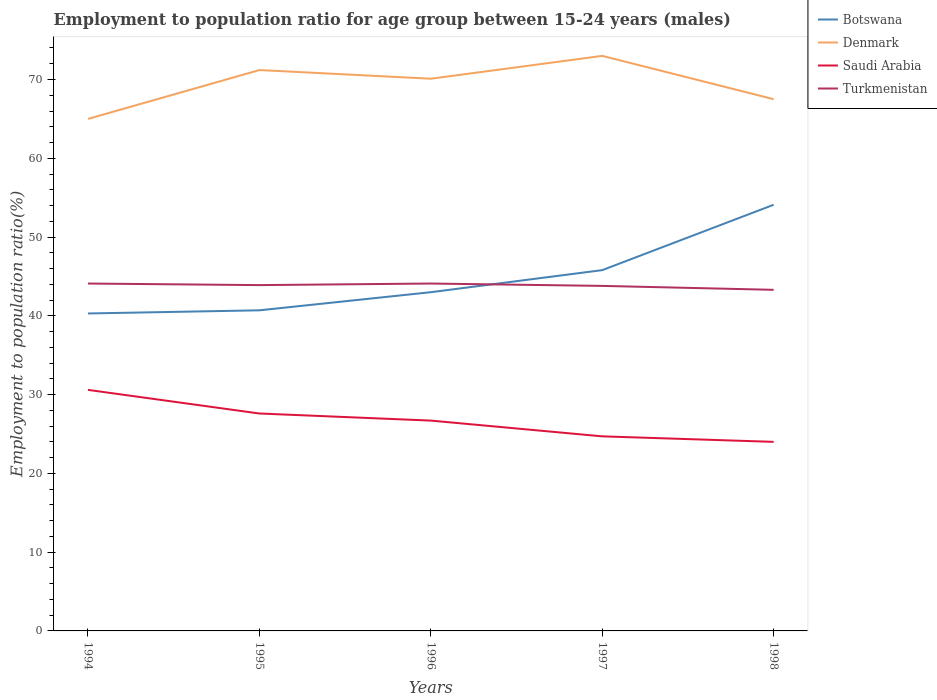Is the number of lines equal to the number of legend labels?
Provide a short and direct response. Yes. Across all years, what is the maximum employment to population ratio in Saudi Arabia?
Your response must be concise. 24. In which year was the employment to population ratio in Denmark maximum?
Make the answer very short. 1994. What is the total employment to population ratio in Saudi Arabia in the graph?
Your response must be concise. 0.9. What is the difference between the highest and the second highest employment to population ratio in Turkmenistan?
Ensure brevity in your answer.  0.8. Is the employment to population ratio in Botswana strictly greater than the employment to population ratio in Saudi Arabia over the years?
Provide a short and direct response. No. How many lines are there?
Your answer should be very brief. 4. How many years are there in the graph?
Make the answer very short. 5. What is the difference between two consecutive major ticks on the Y-axis?
Keep it short and to the point. 10. Does the graph contain grids?
Keep it short and to the point. No. Where does the legend appear in the graph?
Offer a terse response. Top right. How are the legend labels stacked?
Give a very brief answer. Vertical. What is the title of the graph?
Your response must be concise. Employment to population ratio for age group between 15-24 years (males). Does "Lebanon" appear as one of the legend labels in the graph?
Keep it short and to the point. No. What is the label or title of the Y-axis?
Offer a very short reply. Employment to population ratio(%). What is the Employment to population ratio(%) in Botswana in 1994?
Ensure brevity in your answer.  40.3. What is the Employment to population ratio(%) of Denmark in 1994?
Make the answer very short. 65. What is the Employment to population ratio(%) of Saudi Arabia in 1994?
Give a very brief answer. 30.6. What is the Employment to population ratio(%) of Turkmenistan in 1994?
Give a very brief answer. 44.1. What is the Employment to population ratio(%) of Botswana in 1995?
Make the answer very short. 40.7. What is the Employment to population ratio(%) in Denmark in 1995?
Offer a terse response. 71.2. What is the Employment to population ratio(%) in Saudi Arabia in 1995?
Your answer should be compact. 27.6. What is the Employment to population ratio(%) in Turkmenistan in 1995?
Provide a short and direct response. 43.9. What is the Employment to population ratio(%) of Denmark in 1996?
Make the answer very short. 70.1. What is the Employment to population ratio(%) in Saudi Arabia in 1996?
Your response must be concise. 26.7. What is the Employment to population ratio(%) in Turkmenistan in 1996?
Your answer should be very brief. 44.1. What is the Employment to population ratio(%) in Botswana in 1997?
Keep it short and to the point. 45.8. What is the Employment to population ratio(%) in Denmark in 1997?
Provide a short and direct response. 73. What is the Employment to population ratio(%) in Saudi Arabia in 1997?
Give a very brief answer. 24.7. What is the Employment to population ratio(%) in Turkmenistan in 1997?
Ensure brevity in your answer.  43.8. What is the Employment to population ratio(%) in Botswana in 1998?
Give a very brief answer. 54.1. What is the Employment to population ratio(%) in Denmark in 1998?
Give a very brief answer. 67.5. What is the Employment to population ratio(%) in Saudi Arabia in 1998?
Provide a short and direct response. 24. What is the Employment to population ratio(%) in Turkmenistan in 1998?
Ensure brevity in your answer.  43.3. Across all years, what is the maximum Employment to population ratio(%) in Botswana?
Your response must be concise. 54.1. Across all years, what is the maximum Employment to population ratio(%) of Saudi Arabia?
Ensure brevity in your answer.  30.6. Across all years, what is the maximum Employment to population ratio(%) in Turkmenistan?
Offer a very short reply. 44.1. Across all years, what is the minimum Employment to population ratio(%) of Botswana?
Ensure brevity in your answer.  40.3. Across all years, what is the minimum Employment to population ratio(%) in Saudi Arabia?
Your answer should be very brief. 24. Across all years, what is the minimum Employment to population ratio(%) of Turkmenistan?
Make the answer very short. 43.3. What is the total Employment to population ratio(%) in Botswana in the graph?
Ensure brevity in your answer.  223.9. What is the total Employment to population ratio(%) in Denmark in the graph?
Provide a short and direct response. 346.8. What is the total Employment to population ratio(%) in Saudi Arabia in the graph?
Make the answer very short. 133.6. What is the total Employment to population ratio(%) of Turkmenistan in the graph?
Ensure brevity in your answer.  219.2. What is the difference between the Employment to population ratio(%) of Botswana in 1994 and that in 1995?
Offer a very short reply. -0.4. What is the difference between the Employment to population ratio(%) of Denmark in 1994 and that in 1995?
Keep it short and to the point. -6.2. What is the difference between the Employment to population ratio(%) of Turkmenistan in 1994 and that in 1995?
Your answer should be compact. 0.2. What is the difference between the Employment to population ratio(%) in Turkmenistan in 1994 and that in 1996?
Offer a very short reply. 0. What is the difference between the Employment to population ratio(%) in Botswana in 1994 and that in 1997?
Offer a terse response. -5.5. What is the difference between the Employment to population ratio(%) of Turkmenistan in 1994 and that in 1997?
Make the answer very short. 0.3. What is the difference between the Employment to population ratio(%) of Botswana in 1994 and that in 1998?
Keep it short and to the point. -13.8. What is the difference between the Employment to population ratio(%) in Saudi Arabia in 1994 and that in 1998?
Give a very brief answer. 6.6. What is the difference between the Employment to population ratio(%) in Turkmenistan in 1994 and that in 1998?
Offer a terse response. 0.8. What is the difference between the Employment to population ratio(%) in Botswana in 1995 and that in 1996?
Ensure brevity in your answer.  -2.3. What is the difference between the Employment to population ratio(%) in Turkmenistan in 1995 and that in 1996?
Provide a short and direct response. -0.2. What is the difference between the Employment to population ratio(%) of Botswana in 1995 and that in 1997?
Ensure brevity in your answer.  -5.1. What is the difference between the Employment to population ratio(%) of Denmark in 1995 and that in 1997?
Offer a terse response. -1.8. What is the difference between the Employment to population ratio(%) of Denmark in 1995 and that in 1998?
Your answer should be compact. 3.7. What is the difference between the Employment to population ratio(%) of Botswana in 1996 and that in 1997?
Keep it short and to the point. -2.8. What is the difference between the Employment to population ratio(%) in Denmark in 1996 and that in 1997?
Provide a succinct answer. -2.9. What is the difference between the Employment to population ratio(%) in Saudi Arabia in 1996 and that in 1997?
Make the answer very short. 2. What is the difference between the Employment to population ratio(%) of Turkmenistan in 1996 and that in 1997?
Your answer should be compact. 0.3. What is the difference between the Employment to population ratio(%) in Turkmenistan in 1996 and that in 1998?
Provide a succinct answer. 0.8. What is the difference between the Employment to population ratio(%) in Botswana in 1994 and the Employment to population ratio(%) in Denmark in 1995?
Your response must be concise. -30.9. What is the difference between the Employment to population ratio(%) of Botswana in 1994 and the Employment to population ratio(%) of Saudi Arabia in 1995?
Your answer should be very brief. 12.7. What is the difference between the Employment to population ratio(%) in Botswana in 1994 and the Employment to population ratio(%) in Turkmenistan in 1995?
Provide a succinct answer. -3.6. What is the difference between the Employment to population ratio(%) of Denmark in 1994 and the Employment to population ratio(%) of Saudi Arabia in 1995?
Keep it short and to the point. 37.4. What is the difference between the Employment to population ratio(%) in Denmark in 1994 and the Employment to population ratio(%) in Turkmenistan in 1995?
Ensure brevity in your answer.  21.1. What is the difference between the Employment to population ratio(%) in Botswana in 1994 and the Employment to population ratio(%) in Denmark in 1996?
Your response must be concise. -29.8. What is the difference between the Employment to population ratio(%) in Botswana in 1994 and the Employment to population ratio(%) in Saudi Arabia in 1996?
Offer a terse response. 13.6. What is the difference between the Employment to population ratio(%) of Denmark in 1994 and the Employment to population ratio(%) of Saudi Arabia in 1996?
Your response must be concise. 38.3. What is the difference between the Employment to population ratio(%) of Denmark in 1994 and the Employment to population ratio(%) of Turkmenistan in 1996?
Keep it short and to the point. 20.9. What is the difference between the Employment to population ratio(%) of Botswana in 1994 and the Employment to population ratio(%) of Denmark in 1997?
Your response must be concise. -32.7. What is the difference between the Employment to population ratio(%) in Denmark in 1994 and the Employment to population ratio(%) in Saudi Arabia in 1997?
Keep it short and to the point. 40.3. What is the difference between the Employment to population ratio(%) of Denmark in 1994 and the Employment to population ratio(%) of Turkmenistan in 1997?
Your response must be concise. 21.2. What is the difference between the Employment to population ratio(%) of Botswana in 1994 and the Employment to population ratio(%) of Denmark in 1998?
Offer a very short reply. -27.2. What is the difference between the Employment to population ratio(%) in Denmark in 1994 and the Employment to population ratio(%) in Saudi Arabia in 1998?
Provide a short and direct response. 41. What is the difference between the Employment to population ratio(%) in Denmark in 1994 and the Employment to population ratio(%) in Turkmenistan in 1998?
Your answer should be very brief. 21.7. What is the difference between the Employment to population ratio(%) in Saudi Arabia in 1994 and the Employment to population ratio(%) in Turkmenistan in 1998?
Your response must be concise. -12.7. What is the difference between the Employment to population ratio(%) of Botswana in 1995 and the Employment to population ratio(%) of Denmark in 1996?
Offer a terse response. -29.4. What is the difference between the Employment to population ratio(%) in Denmark in 1995 and the Employment to population ratio(%) in Saudi Arabia in 1996?
Provide a short and direct response. 44.5. What is the difference between the Employment to population ratio(%) in Denmark in 1995 and the Employment to population ratio(%) in Turkmenistan in 1996?
Your answer should be very brief. 27.1. What is the difference between the Employment to population ratio(%) of Saudi Arabia in 1995 and the Employment to population ratio(%) of Turkmenistan in 1996?
Your answer should be compact. -16.5. What is the difference between the Employment to population ratio(%) of Botswana in 1995 and the Employment to population ratio(%) of Denmark in 1997?
Offer a terse response. -32.3. What is the difference between the Employment to population ratio(%) in Botswana in 1995 and the Employment to population ratio(%) in Saudi Arabia in 1997?
Give a very brief answer. 16. What is the difference between the Employment to population ratio(%) in Botswana in 1995 and the Employment to population ratio(%) in Turkmenistan in 1997?
Make the answer very short. -3.1. What is the difference between the Employment to population ratio(%) in Denmark in 1995 and the Employment to population ratio(%) in Saudi Arabia in 1997?
Provide a succinct answer. 46.5. What is the difference between the Employment to population ratio(%) of Denmark in 1995 and the Employment to population ratio(%) of Turkmenistan in 1997?
Offer a very short reply. 27.4. What is the difference between the Employment to population ratio(%) of Saudi Arabia in 1995 and the Employment to population ratio(%) of Turkmenistan in 1997?
Give a very brief answer. -16.2. What is the difference between the Employment to population ratio(%) in Botswana in 1995 and the Employment to population ratio(%) in Denmark in 1998?
Offer a terse response. -26.8. What is the difference between the Employment to population ratio(%) in Denmark in 1995 and the Employment to population ratio(%) in Saudi Arabia in 1998?
Give a very brief answer. 47.2. What is the difference between the Employment to population ratio(%) of Denmark in 1995 and the Employment to population ratio(%) of Turkmenistan in 1998?
Provide a short and direct response. 27.9. What is the difference between the Employment to population ratio(%) in Saudi Arabia in 1995 and the Employment to population ratio(%) in Turkmenistan in 1998?
Provide a short and direct response. -15.7. What is the difference between the Employment to population ratio(%) in Botswana in 1996 and the Employment to population ratio(%) in Denmark in 1997?
Your response must be concise. -30. What is the difference between the Employment to population ratio(%) of Botswana in 1996 and the Employment to population ratio(%) of Saudi Arabia in 1997?
Ensure brevity in your answer.  18.3. What is the difference between the Employment to population ratio(%) of Botswana in 1996 and the Employment to population ratio(%) of Turkmenistan in 1997?
Give a very brief answer. -0.8. What is the difference between the Employment to population ratio(%) of Denmark in 1996 and the Employment to population ratio(%) of Saudi Arabia in 1997?
Your answer should be compact. 45.4. What is the difference between the Employment to population ratio(%) of Denmark in 1996 and the Employment to population ratio(%) of Turkmenistan in 1997?
Your answer should be compact. 26.3. What is the difference between the Employment to population ratio(%) of Saudi Arabia in 1996 and the Employment to population ratio(%) of Turkmenistan in 1997?
Make the answer very short. -17.1. What is the difference between the Employment to population ratio(%) of Botswana in 1996 and the Employment to population ratio(%) of Denmark in 1998?
Your answer should be very brief. -24.5. What is the difference between the Employment to population ratio(%) of Botswana in 1996 and the Employment to population ratio(%) of Saudi Arabia in 1998?
Offer a terse response. 19. What is the difference between the Employment to population ratio(%) in Botswana in 1996 and the Employment to population ratio(%) in Turkmenistan in 1998?
Your response must be concise. -0.3. What is the difference between the Employment to population ratio(%) of Denmark in 1996 and the Employment to population ratio(%) of Saudi Arabia in 1998?
Give a very brief answer. 46.1. What is the difference between the Employment to population ratio(%) of Denmark in 1996 and the Employment to population ratio(%) of Turkmenistan in 1998?
Ensure brevity in your answer.  26.8. What is the difference between the Employment to population ratio(%) of Saudi Arabia in 1996 and the Employment to population ratio(%) of Turkmenistan in 1998?
Offer a very short reply. -16.6. What is the difference between the Employment to population ratio(%) in Botswana in 1997 and the Employment to population ratio(%) in Denmark in 1998?
Make the answer very short. -21.7. What is the difference between the Employment to population ratio(%) of Botswana in 1997 and the Employment to population ratio(%) of Saudi Arabia in 1998?
Make the answer very short. 21.8. What is the difference between the Employment to population ratio(%) in Denmark in 1997 and the Employment to population ratio(%) in Saudi Arabia in 1998?
Keep it short and to the point. 49. What is the difference between the Employment to population ratio(%) of Denmark in 1997 and the Employment to population ratio(%) of Turkmenistan in 1998?
Make the answer very short. 29.7. What is the difference between the Employment to population ratio(%) in Saudi Arabia in 1997 and the Employment to population ratio(%) in Turkmenistan in 1998?
Offer a very short reply. -18.6. What is the average Employment to population ratio(%) of Botswana per year?
Provide a short and direct response. 44.78. What is the average Employment to population ratio(%) of Denmark per year?
Your response must be concise. 69.36. What is the average Employment to population ratio(%) of Saudi Arabia per year?
Your response must be concise. 26.72. What is the average Employment to population ratio(%) in Turkmenistan per year?
Ensure brevity in your answer.  43.84. In the year 1994, what is the difference between the Employment to population ratio(%) in Botswana and Employment to population ratio(%) in Denmark?
Ensure brevity in your answer.  -24.7. In the year 1994, what is the difference between the Employment to population ratio(%) in Botswana and Employment to population ratio(%) in Turkmenistan?
Your answer should be very brief. -3.8. In the year 1994, what is the difference between the Employment to population ratio(%) in Denmark and Employment to population ratio(%) in Saudi Arabia?
Offer a very short reply. 34.4. In the year 1994, what is the difference between the Employment to population ratio(%) in Denmark and Employment to population ratio(%) in Turkmenistan?
Your answer should be very brief. 20.9. In the year 1995, what is the difference between the Employment to population ratio(%) in Botswana and Employment to population ratio(%) in Denmark?
Offer a very short reply. -30.5. In the year 1995, what is the difference between the Employment to population ratio(%) in Botswana and Employment to population ratio(%) in Turkmenistan?
Ensure brevity in your answer.  -3.2. In the year 1995, what is the difference between the Employment to population ratio(%) in Denmark and Employment to population ratio(%) in Saudi Arabia?
Provide a succinct answer. 43.6. In the year 1995, what is the difference between the Employment to population ratio(%) of Denmark and Employment to population ratio(%) of Turkmenistan?
Give a very brief answer. 27.3. In the year 1995, what is the difference between the Employment to population ratio(%) of Saudi Arabia and Employment to population ratio(%) of Turkmenistan?
Make the answer very short. -16.3. In the year 1996, what is the difference between the Employment to population ratio(%) in Botswana and Employment to population ratio(%) in Denmark?
Ensure brevity in your answer.  -27.1. In the year 1996, what is the difference between the Employment to population ratio(%) in Botswana and Employment to population ratio(%) in Turkmenistan?
Provide a short and direct response. -1.1. In the year 1996, what is the difference between the Employment to population ratio(%) in Denmark and Employment to population ratio(%) in Saudi Arabia?
Provide a short and direct response. 43.4. In the year 1996, what is the difference between the Employment to population ratio(%) in Saudi Arabia and Employment to population ratio(%) in Turkmenistan?
Ensure brevity in your answer.  -17.4. In the year 1997, what is the difference between the Employment to population ratio(%) of Botswana and Employment to population ratio(%) of Denmark?
Keep it short and to the point. -27.2. In the year 1997, what is the difference between the Employment to population ratio(%) in Botswana and Employment to population ratio(%) in Saudi Arabia?
Your response must be concise. 21.1. In the year 1997, what is the difference between the Employment to population ratio(%) of Botswana and Employment to population ratio(%) of Turkmenistan?
Your answer should be compact. 2. In the year 1997, what is the difference between the Employment to population ratio(%) of Denmark and Employment to population ratio(%) of Saudi Arabia?
Keep it short and to the point. 48.3. In the year 1997, what is the difference between the Employment to population ratio(%) in Denmark and Employment to population ratio(%) in Turkmenistan?
Make the answer very short. 29.2. In the year 1997, what is the difference between the Employment to population ratio(%) in Saudi Arabia and Employment to population ratio(%) in Turkmenistan?
Your response must be concise. -19.1. In the year 1998, what is the difference between the Employment to population ratio(%) of Botswana and Employment to population ratio(%) of Denmark?
Keep it short and to the point. -13.4. In the year 1998, what is the difference between the Employment to population ratio(%) in Botswana and Employment to population ratio(%) in Saudi Arabia?
Make the answer very short. 30.1. In the year 1998, what is the difference between the Employment to population ratio(%) in Botswana and Employment to population ratio(%) in Turkmenistan?
Your answer should be compact. 10.8. In the year 1998, what is the difference between the Employment to population ratio(%) of Denmark and Employment to population ratio(%) of Saudi Arabia?
Keep it short and to the point. 43.5. In the year 1998, what is the difference between the Employment to population ratio(%) in Denmark and Employment to population ratio(%) in Turkmenistan?
Offer a very short reply. 24.2. In the year 1998, what is the difference between the Employment to population ratio(%) in Saudi Arabia and Employment to population ratio(%) in Turkmenistan?
Offer a terse response. -19.3. What is the ratio of the Employment to population ratio(%) in Botswana in 1994 to that in 1995?
Offer a terse response. 0.99. What is the ratio of the Employment to population ratio(%) in Denmark in 1994 to that in 1995?
Your response must be concise. 0.91. What is the ratio of the Employment to population ratio(%) of Saudi Arabia in 1994 to that in 1995?
Give a very brief answer. 1.11. What is the ratio of the Employment to population ratio(%) in Botswana in 1994 to that in 1996?
Your response must be concise. 0.94. What is the ratio of the Employment to population ratio(%) in Denmark in 1994 to that in 1996?
Keep it short and to the point. 0.93. What is the ratio of the Employment to population ratio(%) of Saudi Arabia in 1994 to that in 1996?
Provide a short and direct response. 1.15. What is the ratio of the Employment to population ratio(%) in Turkmenistan in 1994 to that in 1996?
Offer a terse response. 1. What is the ratio of the Employment to population ratio(%) of Botswana in 1994 to that in 1997?
Your answer should be compact. 0.88. What is the ratio of the Employment to population ratio(%) in Denmark in 1994 to that in 1997?
Provide a succinct answer. 0.89. What is the ratio of the Employment to population ratio(%) in Saudi Arabia in 1994 to that in 1997?
Offer a terse response. 1.24. What is the ratio of the Employment to population ratio(%) in Turkmenistan in 1994 to that in 1997?
Keep it short and to the point. 1.01. What is the ratio of the Employment to population ratio(%) of Botswana in 1994 to that in 1998?
Your response must be concise. 0.74. What is the ratio of the Employment to population ratio(%) in Denmark in 1994 to that in 1998?
Offer a terse response. 0.96. What is the ratio of the Employment to population ratio(%) of Saudi Arabia in 1994 to that in 1998?
Your response must be concise. 1.27. What is the ratio of the Employment to population ratio(%) in Turkmenistan in 1994 to that in 1998?
Your response must be concise. 1.02. What is the ratio of the Employment to population ratio(%) in Botswana in 1995 to that in 1996?
Keep it short and to the point. 0.95. What is the ratio of the Employment to population ratio(%) of Denmark in 1995 to that in 1996?
Ensure brevity in your answer.  1.02. What is the ratio of the Employment to population ratio(%) in Saudi Arabia in 1995 to that in 1996?
Offer a very short reply. 1.03. What is the ratio of the Employment to population ratio(%) in Turkmenistan in 1995 to that in 1996?
Provide a succinct answer. 1. What is the ratio of the Employment to population ratio(%) of Botswana in 1995 to that in 1997?
Keep it short and to the point. 0.89. What is the ratio of the Employment to population ratio(%) in Denmark in 1995 to that in 1997?
Ensure brevity in your answer.  0.98. What is the ratio of the Employment to population ratio(%) in Saudi Arabia in 1995 to that in 1997?
Your answer should be compact. 1.12. What is the ratio of the Employment to population ratio(%) in Turkmenistan in 1995 to that in 1997?
Make the answer very short. 1. What is the ratio of the Employment to population ratio(%) in Botswana in 1995 to that in 1998?
Your answer should be very brief. 0.75. What is the ratio of the Employment to population ratio(%) of Denmark in 1995 to that in 1998?
Ensure brevity in your answer.  1.05. What is the ratio of the Employment to population ratio(%) of Saudi Arabia in 1995 to that in 1998?
Offer a very short reply. 1.15. What is the ratio of the Employment to population ratio(%) in Turkmenistan in 1995 to that in 1998?
Provide a succinct answer. 1.01. What is the ratio of the Employment to population ratio(%) of Botswana in 1996 to that in 1997?
Make the answer very short. 0.94. What is the ratio of the Employment to population ratio(%) of Denmark in 1996 to that in 1997?
Offer a terse response. 0.96. What is the ratio of the Employment to population ratio(%) of Saudi Arabia in 1996 to that in 1997?
Offer a terse response. 1.08. What is the ratio of the Employment to population ratio(%) in Turkmenistan in 1996 to that in 1997?
Give a very brief answer. 1.01. What is the ratio of the Employment to population ratio(%) of Botswana in 1996 to that in 1998?
Your response must be concise. 0.79. What is the ratio of the Employment to population ratio(%) of Denmark in 1996 to that in 1998?
Ensure brevity in your answer.  1.04. What is the ratio of the Employment to population ratio(%) in Saudi Arabia in 1996 to that in 1998?
Make the answer very short. 1.11. What is the ratio of the Employment to population ratio(%) in Turkmenistan in 1996 to that in 1998?
Your answer should be compact. 1.02. What is the ratio of the Employment to population ratio(%) in Botswana in 1997 to that in 1998?
Provide a succinct answer. 0.85. What is the ratio of the Employment to population ratio(%) in Denmark in 1997 to that in 1998?
Your response must be concise. 1.08. What is the ratio of the Employment to population ratio(%) of Saudi Arabia in 1997 to that in 1998?
Make the answer very short. 1.03. What is the ratio of the Employment to population ratio(%) in Turkmenistan in 1997 to that in 1998?
Make the answer very short. 1.01. What is the difference between the highest and the second highest Employment to population ratio(%) in Botswana?
Offer a terse response. 8.3. What is the difference between the highest and the second highest Employment to population ratio(%) in Denmark?
Your answer should be very brief. 1.8. What is the difference between the highest and the second highest Employment to population ratio(%) of Saudi Arabia?
Your answer should be compact. 3. What is the difference between the highest and the lowest Employment to population ratio(%) in Denmark?
Give a very brief answer. 8. What is the difference between the highest and the lowest Employment to population ratio(%) of Saudi Arabia?
Make the answer very short. 6.6. 